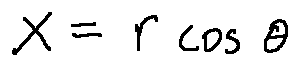<formula> <loc_0><loc_0><loc_500><loc_500>x = r \cos \theta</formula> 